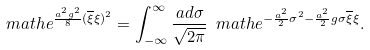Convert formula to latex. <formula><loc_0><loc_0><loc_500><loc_500>\ m a t h e ^ { \frac { a ^ { 2 } g ^ { 2 } } { 8 } ( \overline { \xi } \xi ) ^ { 2 } } = \int _ { - \infty } ^ { \infty } \frac { a d \sigma } { \sqrt { 2 \pi } } \ m a t h e ^ { - \frac { a ^ { 2 } } { 2 } \sigma ^ { 2 } - \frac { a ^ { 2 } } { 2 } g \sigma \overline { \xi } \xi } .</formula> 